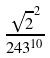<formula> <loc_0><loc_0><loc_500><loc_500>\frac { \sqrt { 2 } ^ { 2 } } { 2 4 3 ^ { 1 0 } }</formula> 